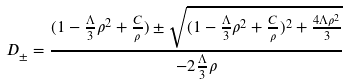<formula> <loc_0><loc_0><loc_500><loc_500>D _ { \pm } = \frac { ( 1 - \frac { \Lambda } { 3 } \rho ^ { 2 } + \frac { C } { \rho } ) \pm \sqrt { ( 1 - \frac { \Lambda } { 3 } \rho ^ { 2 } + \frac { C } { \rho } ) ^ { 2 } + \frac { 4 \Lambda \rho ^ { 2 } } 3 } } { - 2 \frac { \Lambda } { 3 } \rho }</formula> 